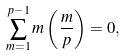Convert formula to latex. <formula><loc_0><loc_0><loc_500><loc_500>\sum _ { m = 1 } ^ { p - 1 } m \left ( \frac { m } { p } \right ) = 0 ,</formula> 